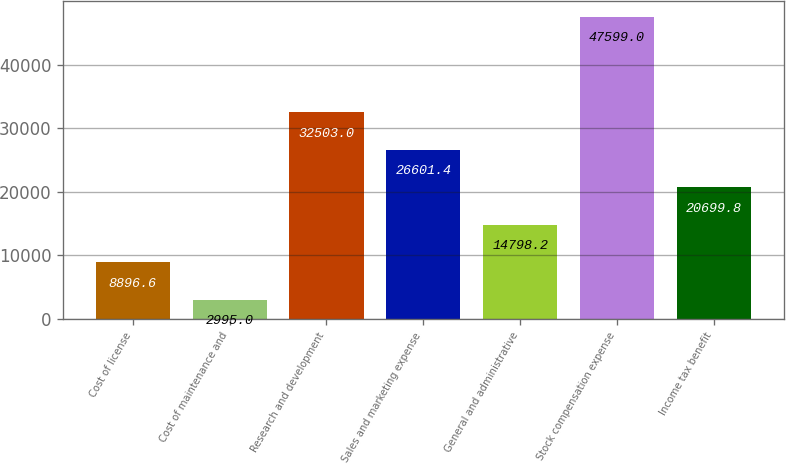Convert chart to OTSL. <chart><loc_0><loc_0><loc_500><loc_500><bar_chart><fcel>Cost of license<fcel>Cost of maintenance and<fcel>Research and development<fcel>Sales and marketing expense<fcel>General and administrative<fcel>Stock compensation expense<fcel>Income tax benefit<nl><fcel>8896.6<fcel>2995<fcel>32503<fcel>26601.4<fcel>14798.2<fcel>47599<fcel>20699.8<nl></chart> 